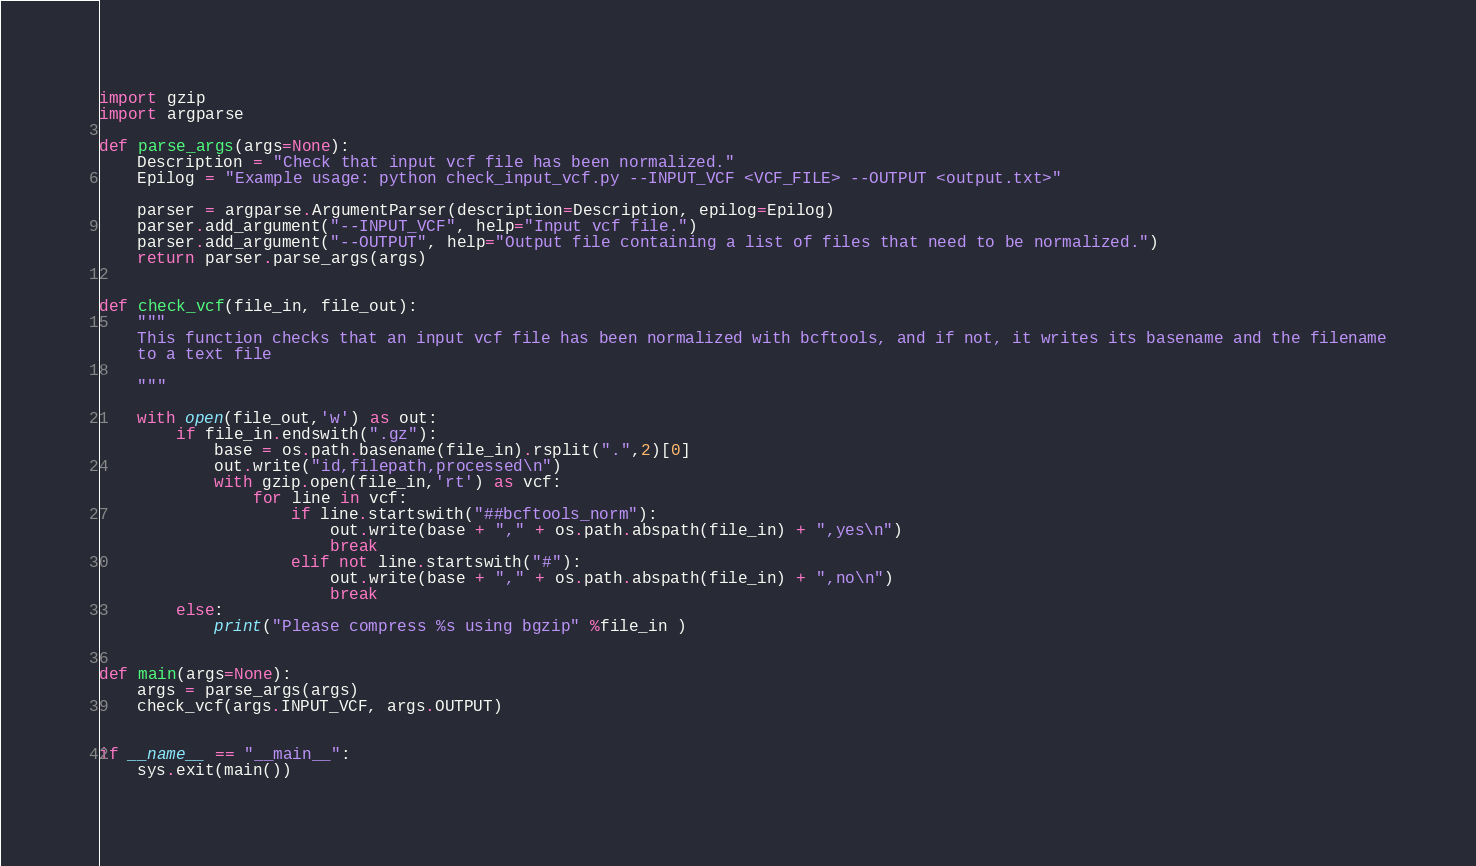<code> <loc_0><loc_0><loc_500><loc_500><_Python_>import gzip
import argparse

def parse_args(args=None):
    Description = "Check that input vcf file has been normalized."
    Epilog = "Example usage: python check_input_vcf.py --INPUT_VCF <VCF_FILE> --OUTPUT <output.txt>"

    parser = argparse.ArgumentParser(description=Description, epilog=Epilog)
    parser.add_argument("--INPUT_VCF", help="Input vcf file.")
    parser.add_argument("--OUTPUT", help="Output file containing a list of files that need to be normalized.")
    return parser.parse_args(args)


def check_vcf(file_in, file_out):
    """
    This function checks that an input vcf file has been normalized with bcftools, and if not, it writes its basename and the filename
    to a text file

    """

    with open(file_out,'w') as out:
        if file_in.endswith(".gz"):
            base = os.path.basename(file_in).rsplit(".",2)[0]
            out.write("id,filepath,processed\n")
            with gzip.open(file_in,'rt') as vcf:
                for line in vcf:
                    if line.startswith("##bcftools_norm"):
                        out.write(base + "," + os.path.abspath(file_in) + ",yes\n")
                        break
                    elif not line.startswith("#"):
                        out.write(base + "," + os.path.abspath(file_in) + ",no\n")
                        break
        else:
            print("Please compress %s using bgzip" %file_in )


def main(args=None):
    args = parse_args(args)
    check_vcf(args.INPUT_VCF, args.OUTPUT)


if __name__ == "__main__":
    sys.exit(main())
</code> 